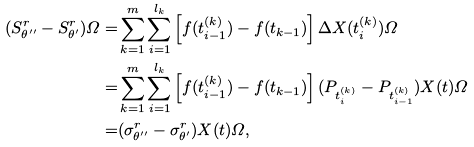Convert formula to latex. <formula><loc_0><loc_0><loc_500><loc_500>( S _ { \theta ^ { \prime \prime } } ^ { r } - S _ { \theta ^ { \prime } } ^ { r } ) \varOmega = & \sum _ { k = 1 } ^ { m } \sum _ { i = 1 } ^ { l _ { k } } \left [ f ( t _ { i - 1 } ^ { ( k ) } ) - f ( t _ { k - 1 } ) \right ] \Delta X ( t _ { i } ^ { ( k ) } ) \varOmega \\ = & \sum _ { k = 1 } ^ { m } \sum _ { i = 1 } ^ { l _ { k } } \left [ f ( t _ { i - 1 } ^ { ( k ) } ) - f ( t _ { k - 1 } ) \right ] ( P _ { t _ { i } ^ { ( k ) } } - P _ { t _ { i - 1 } ^ { ( k ) } } ) X ( t ) \varOmega \\ = & ( \sigma _ { \theta ^ { \prime \prime } } ^ { r } - \sigma _ { \theta ^ { \prime } } ^ { r } ) X ( t ) \varOmega ,</formula> 